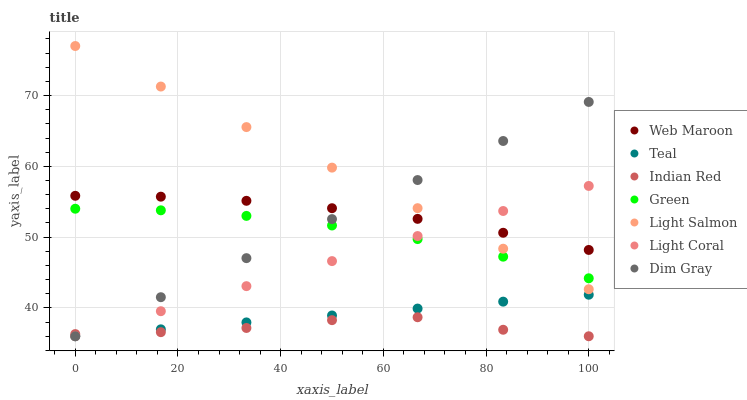Does Indian Red have the minimum area under the curve?
Answer yes or no. Yes. Does Light Salmon have the maximum area under the curve?
Answer yes or no. Yes. Does Dim Gray have the minimum area under the curve?
Answer yes or no. No. Does Dim Gray have the maximum area under the curve?
Answer yes or no. No. Is Dim Gray the smoothest?
Answer yes or no. Yes. Is Indian Red the roughest?
Answer yes or no. Yes. Is Teal the smoothest?
Answer yes or no. No. Is Teal the roughest?
Answer yes or no. No. Does Dim Gray have the lowest value?
Answer yes or no. Yes. Does Web Maroon have the lowest value?
Answer yes or no. No. Does Light Salmon have the highest value?
Answer yes or no. Yes. Does Dim Gray have the highest value?
Answer yes or no. No. Is Indian Red less than Green?
Answer yes or no. Yes. Is Light Salmon greater than Teal?
Answer yes or no. Yes. Does Light Coral intersect Green?
Answer yes or no. Yes. Is Light Coral less than Green?
Answer yes or no. No. Is Light Coral greater than Green?
Answer yes or no. No. Does Indian Red intersect Green?
Answer yes or no. No. 